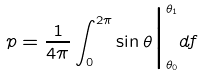<formula> <loc_0><loc_0><loc_500><loc_500>p = \frac { 1 } { 4 \pi } \int _ { 0 } ^ { 2 \pi } \sin \theta \Big | ^ { \theta _ { 1 } } _ { \theta _ { 0 } } d f</formula> 